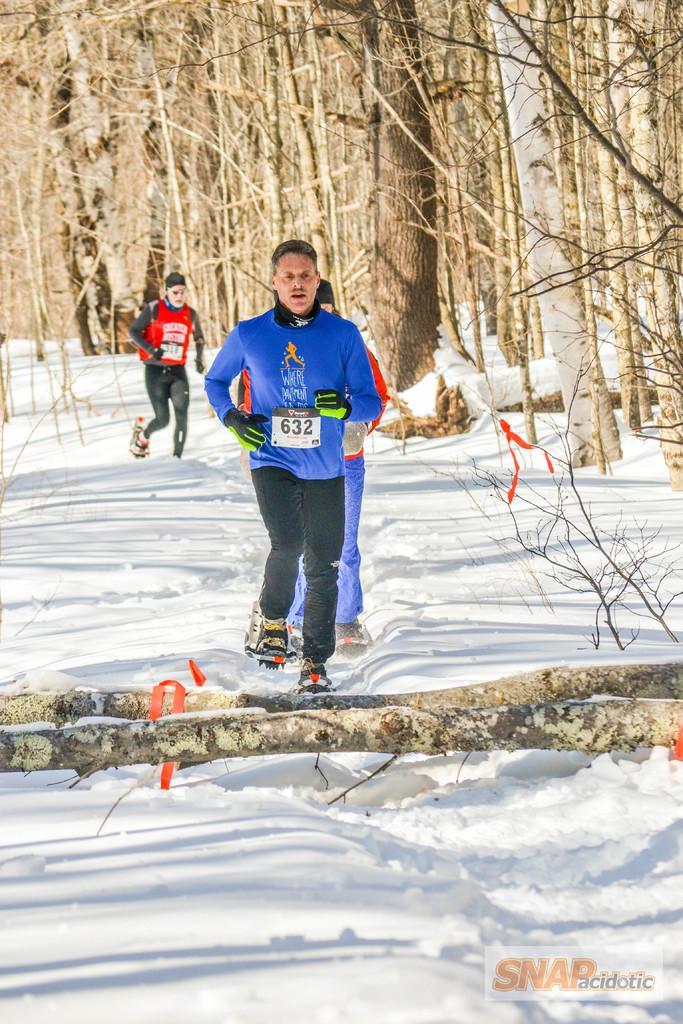In one or two sentences, can you explain what this image depicts? In this image I can see three people with the ski boards. These people are wearing the different color dresses and I can see they are on the snow. In-front of these people I can see the branches of the tree. In the back there are many trees. 